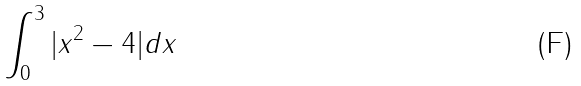Convert formula to latex. <formula><loc_0><loc_0><loc_500><loc_500>\int _ { 0 } ^ { 3 } | x ^ { 2 } - 4 | d x</formula> 